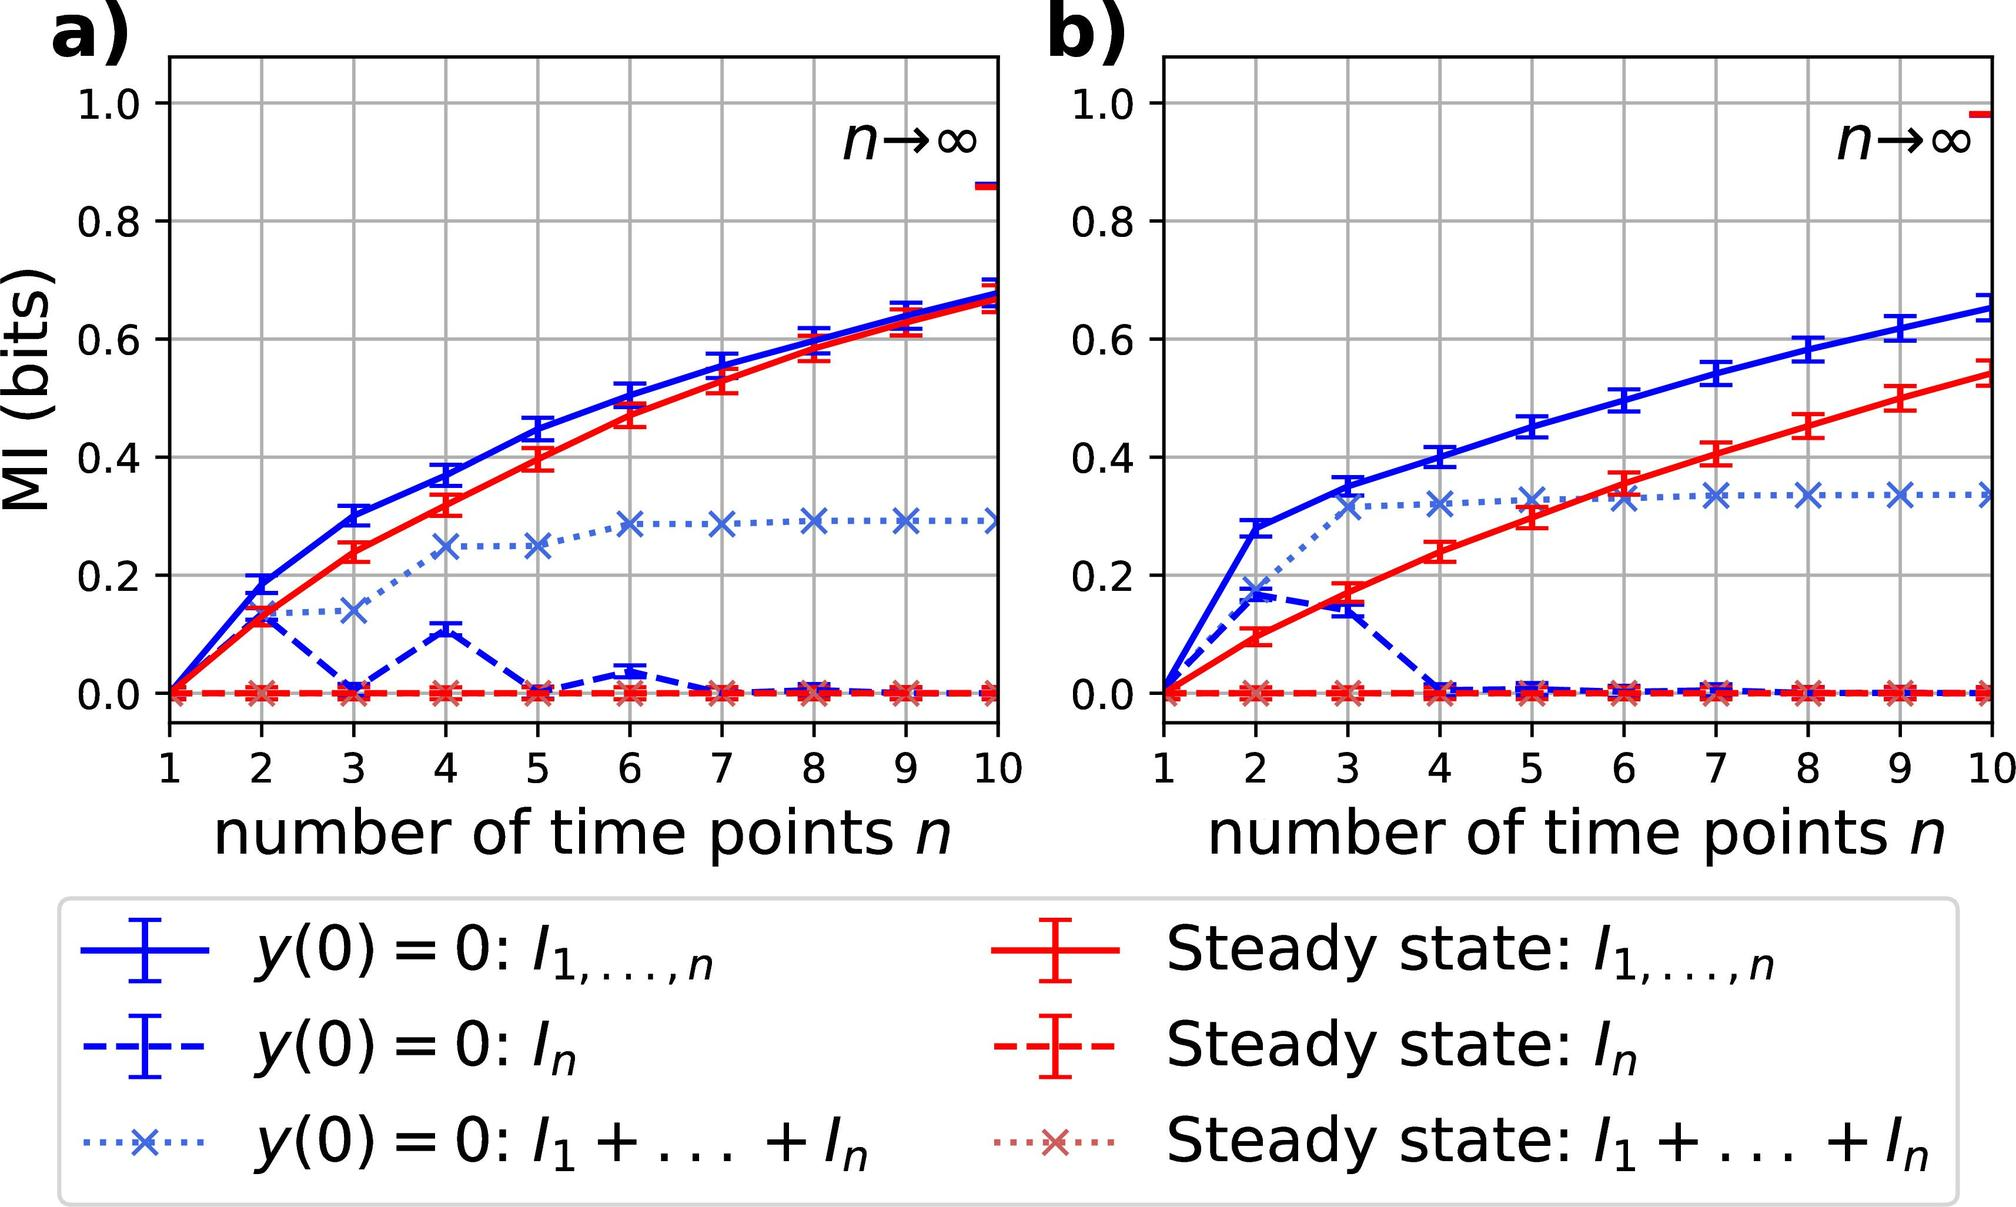Can you explain what mutual information (MI) signifies in this context? In the context of these graphs, mutual information (MI) quantifies the amount of information shared between different time points in a system or process. It measures the reduction of uncertainty about one random variable (such as a time point's state) given the knowledge of another. Higher MI values suggest a greater degree of predictive power or dependence between time points, while lower MI values indicate less shared information or independence. 